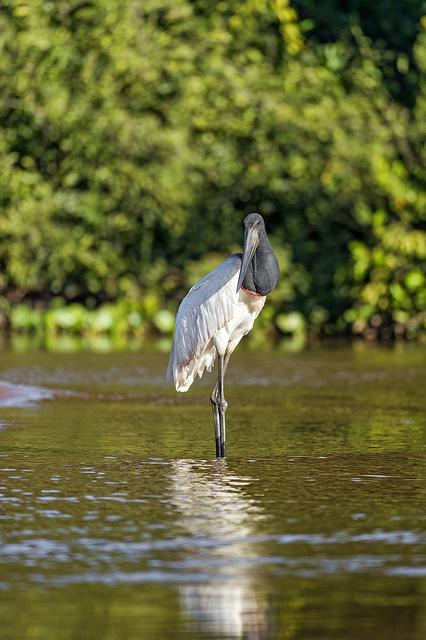Is the bird in the water?
Write a very short answer. Yes. What is the bird looking for?
Give a very brief answer. Food. Is the bird drinking water?
Give a very brief answer. No. Is the background in focus?
Answer briefly. No. 